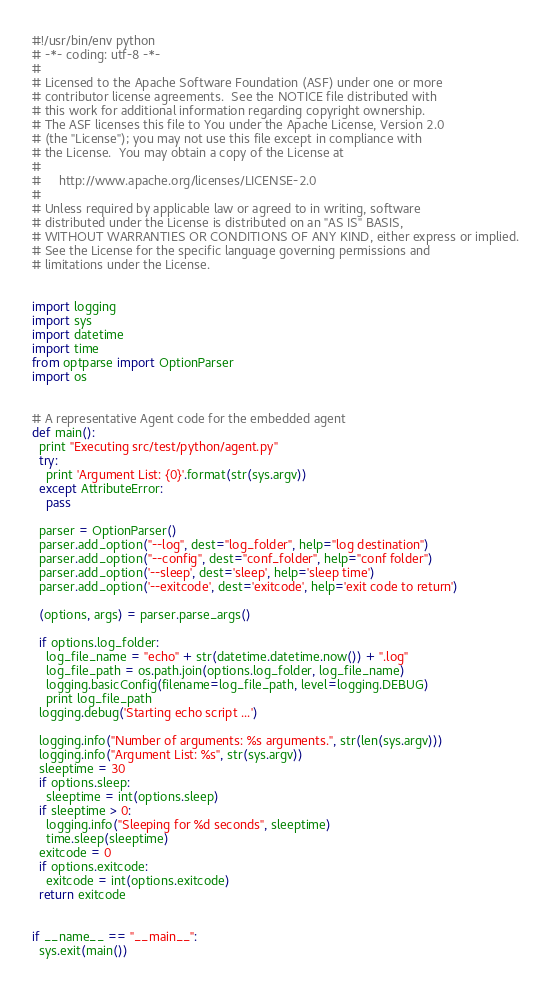Convert code to text. <code><loc_0><loc_0><loc_500><loc_500><_Python_>#!/usr/bin/env python
# -*- coding: utf-8 -*-
#
# Licensed to the Apache Software Foundation (ASF) under one or more
# contributor license agreements.  See the NOTICE file distributed with
# this work for additional information regarding copyright ownership.
# The ASF licenses this file to You under the Apache License, Version 2.0
# (the "License"); you may not use this file except in compliance with
# the License.  You may obtain a copy of the License at
#
#     http://www.apache.org/licenses/LICENSE-2.0
#
# Unless required by applicable law or agreed to in writing, software
# distributed under the License is distributed on an "AS IS" BASIS,
# WITHOUT WARRANTIES OR CONDITIONS OF ANY KIND, either express or implied.
# See the License for the specific language governing permissions and
# limitations under the License.


import logging
import sys
import datetime
import time
from optparse import OptionParser
import os


# A representative Agent code for the embedded agent
def main():
  print "Executing src/test/python/agent.py"
  try:
    print 'Argument List: {0}'.format(str(sys.argv))
  except AttributeError:
    pass

  parser = OptionParser()
  parser.add_option("--log", dest="log_folder", help="log destination")
  parser.add_option("--config", dest="conf_folder", help="conf folder")
  parser.add_option('--sleep', dest='sleep', help='sleep time')
  parser.add_option('--exitcode', dest='exitcode', help='exit code to return')

  (options, args) = parser.parse_args()

  if options.log_folder:
    log_file_name = "echo" + str(datetime.datetime.now()) + ".log"
    log_file_path = os.path.join(options.log_folder, log_file_name)
    logging.basicConfig(filename=log_file_path, level=logging.DEBUG)
    print log_file_path
  logging.debug('Starting echo script ...')

  logging.info("Number of arguments: %s arguments.", str(len(sys.argv)))
  logging.info("Argument List: %s", str(sys.argv))
  sleeptime = 30
  if options.sleep:
    sleeptime = int(options.sleep)
  if sleeptime > 0:
    logging.info("Sleeping for %d seconds", sleeptime)
    time.sleep(sleeptime)
  exitcode = 0
  if options.exitcode:
    exitcode = int(options.exitcode)
  return exitcode


if __name__ == "__main__":
  sys.exit(main())
</code> 